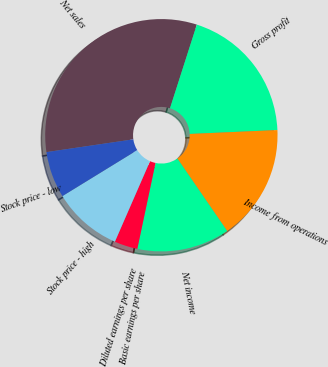Convert chart. <chart><loc_0><loc_0><loc_500><loc_500><pie_chart><fcel>Net sales<fcel>Gross profit<fcel>Income from operations<fcel>Net income<fcel>Basic earnings per share<fcel>Diluted earnings per share<fcel>Stock price - high<fcel>Stock price - low<nl><fcel>32.26%<fcel>19.35%<fcel>16.13%<fcel>12.9%<fcel>0.0%<fcel>3.23%<fcel>9.68%<fcel>6.45%<nl></chart> 